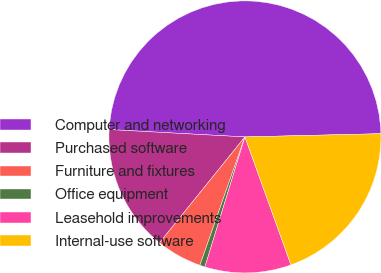Convert chart. <chart><loc_0><loc_0><loc_500><loc_500><pie_chart><fcel>Computer and networking<fcel>Purchased software<fcel>Furniture and fixtures<fcel>Office equipment<fcel>Leasehold improvements<fcel>Internal-use software<nl><fcel>48.76%<fcel>15.06%<fcel>5.43%<fcel>0.62%<fcel>10.25%<fcel>19.88%<nl></chart> 